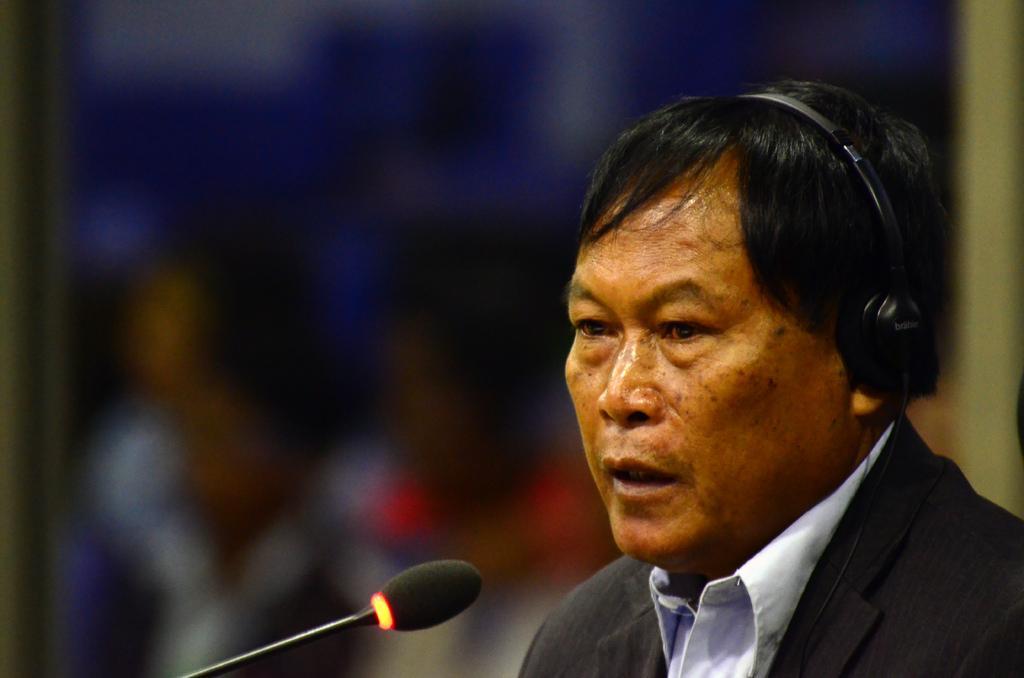Please provide a concise description of this image. In this image we can see a man with headset and a mic is placed in front of him. 